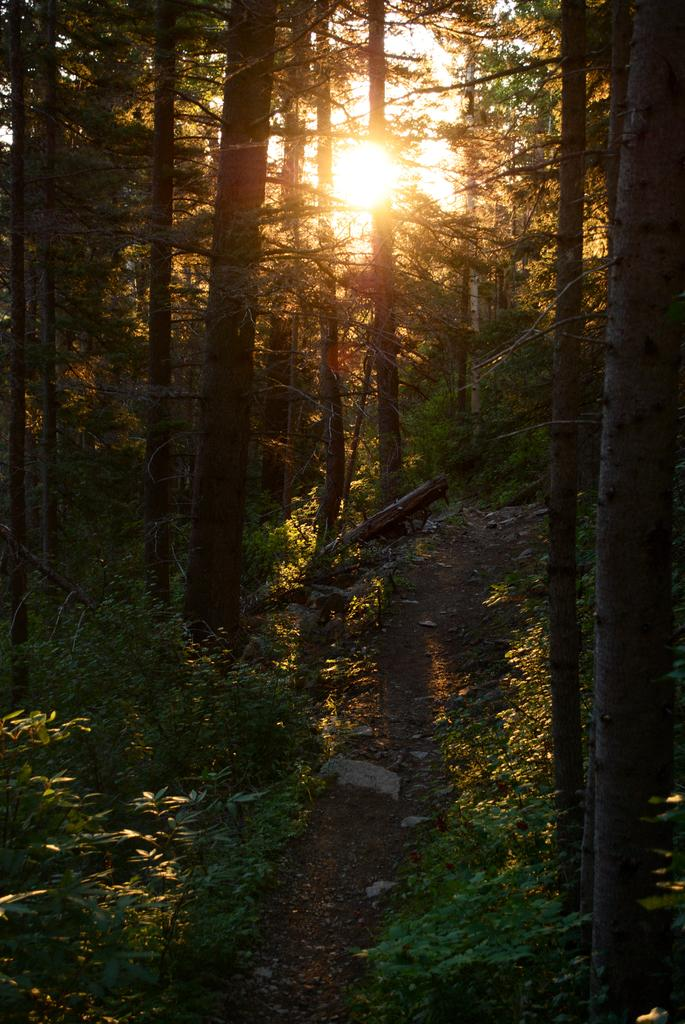What type of vegetation can be seen in the image? There are trees in the image. What is present on the floor in the image? There is soil and rocks on the floor in the image. What is the condition of the sky in the image? The sky is clear in the image. How many pies are visible in the image? There are no pies present in the image. What type of iron object can be seen in the image? There is no iron object present in the image. 